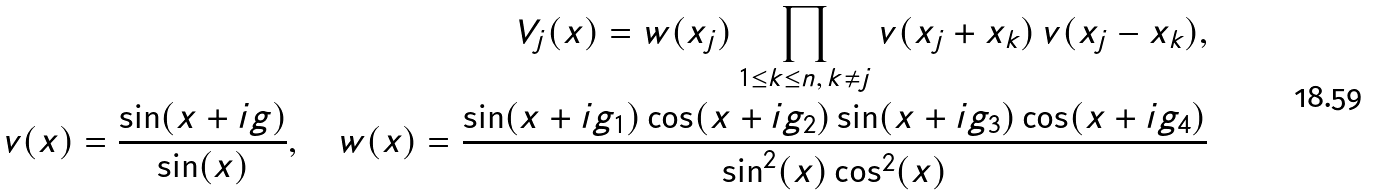Convert formula to latex. <formula><loc_0><loc_0><loc_500><loc_500>V _ { j } ( x ) = w ( x _ { j } ) \prod _ { 1 \leq k \leq n , \, k \neq j } v ( x _ { j } + x _ { k } ) \, v ( x _ { j } - x _ { k } ) , \\ v ( x ) = \frac { \sin ( x + i g ) } { \sin ( x ) } , \quad w ( x ) = \frac { \sin ( x + i g _ { 1 } ) \cos ( x + i g _ { 2 } ) \sin ( x + i g _ { 3 } ) \cos ( x + i g _ { 4 } ) } { \sin ^ { 2 } ( x ) \cos ^ { 2 } ( x ) }</formula> 